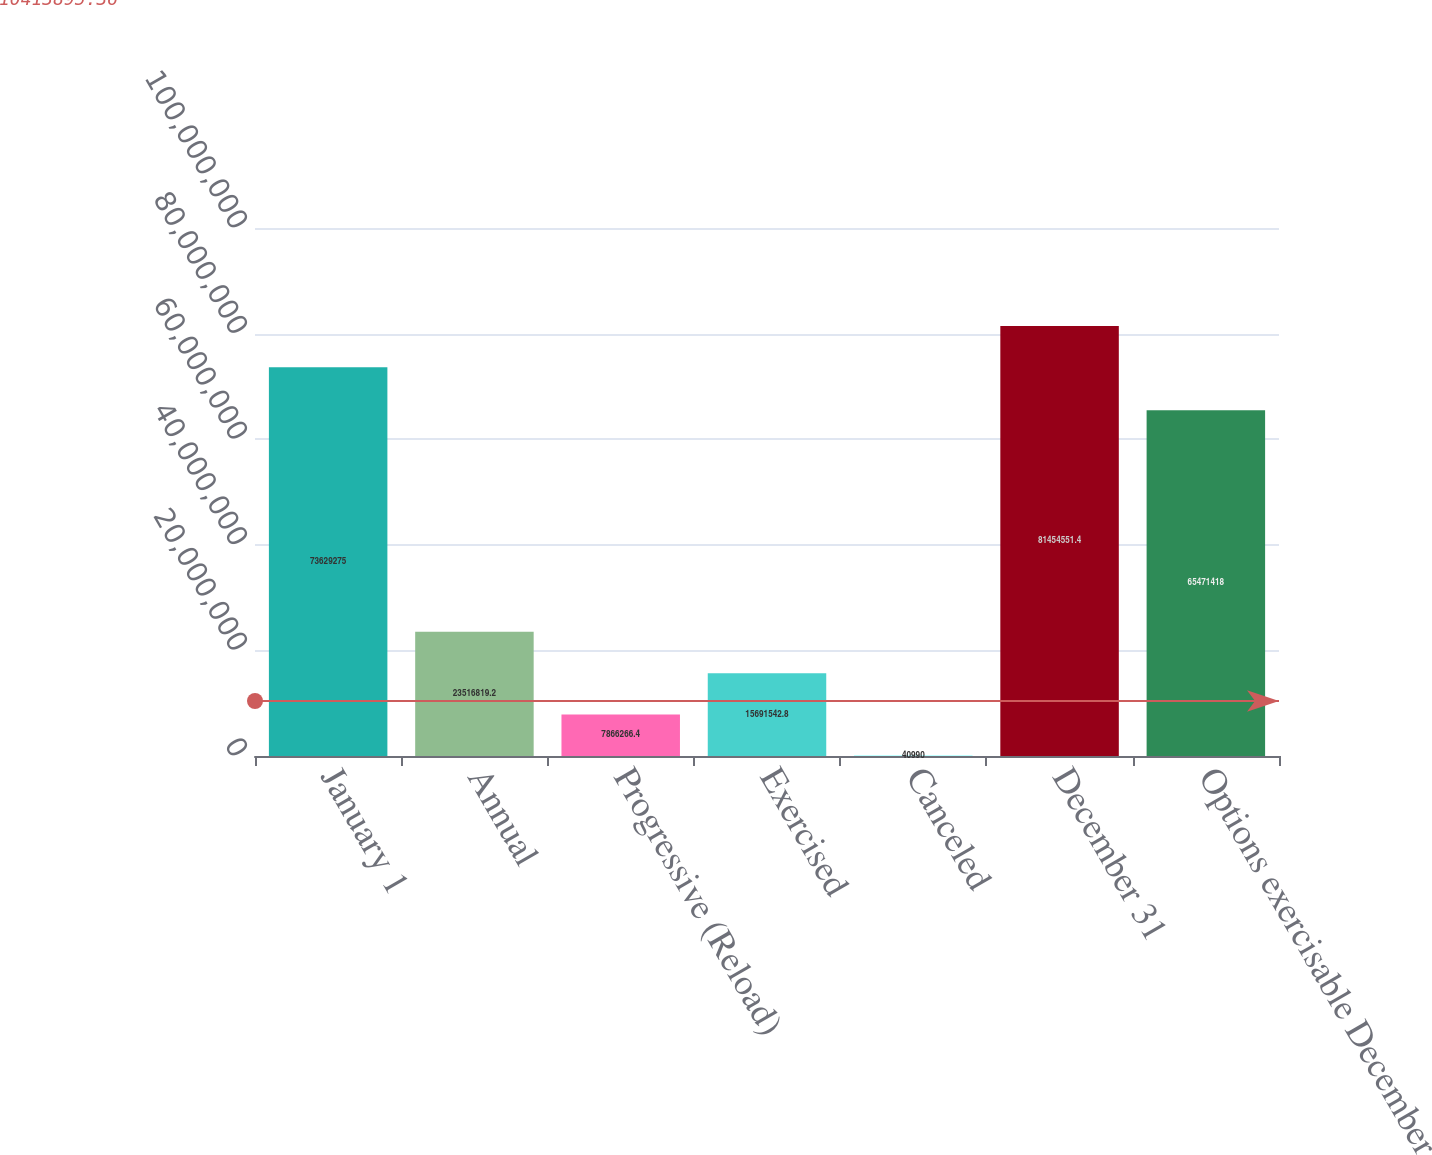<chart> <loc_0><loc_0><loc_500><loc_500><bar_chart><fcel>January 1<fcel>Annual<fcel>Progressive (Reload)<fcel>Exercised<fcel>Canceled<fcel>December 31<fcel>Options exercisable December<nl><fcel>7.36293e+07<fcel>2.35168e+07<fcel>7.86627e+06<fcel>1.56915e+07<fcel>40990<fcel>8.14546e+07<fcel>6.54714e+07<nl></chart> 